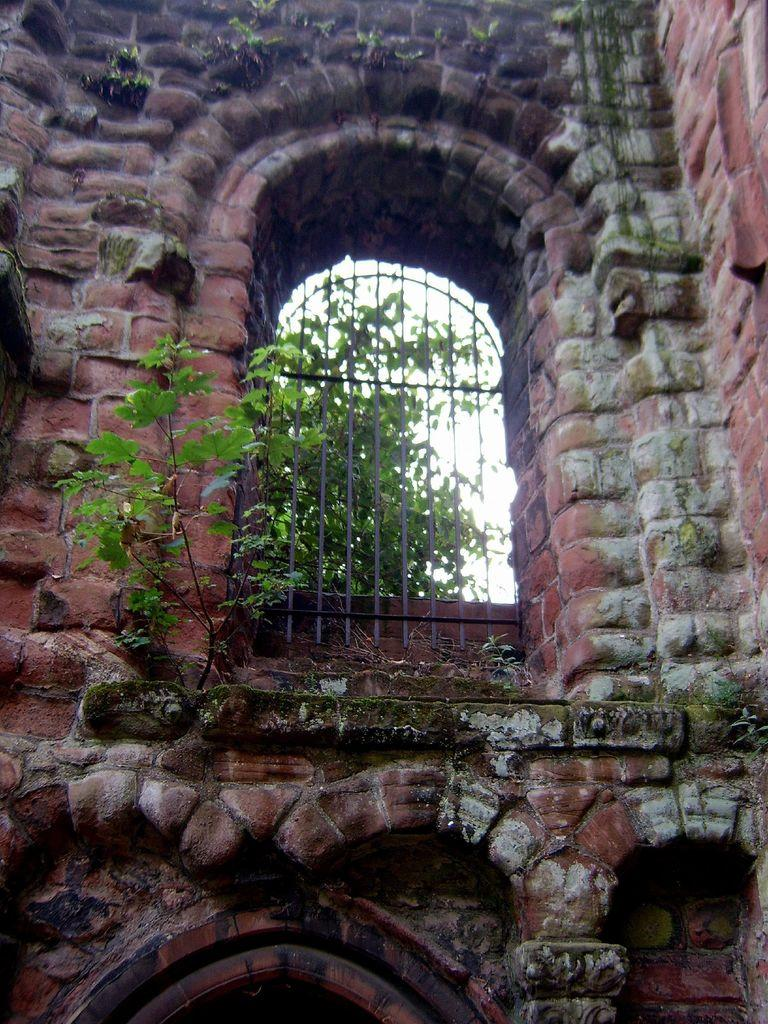What color is the wall that can be seen in the image? The wall in the image is red. What architectural feature is present in the wall? There is a window in the wall. What type of vegetation is visible in the image? There are plants in the image. What type of breakfast is being served on the chalkboard in the image? There is no chalkboard or breakfast present in the image. 